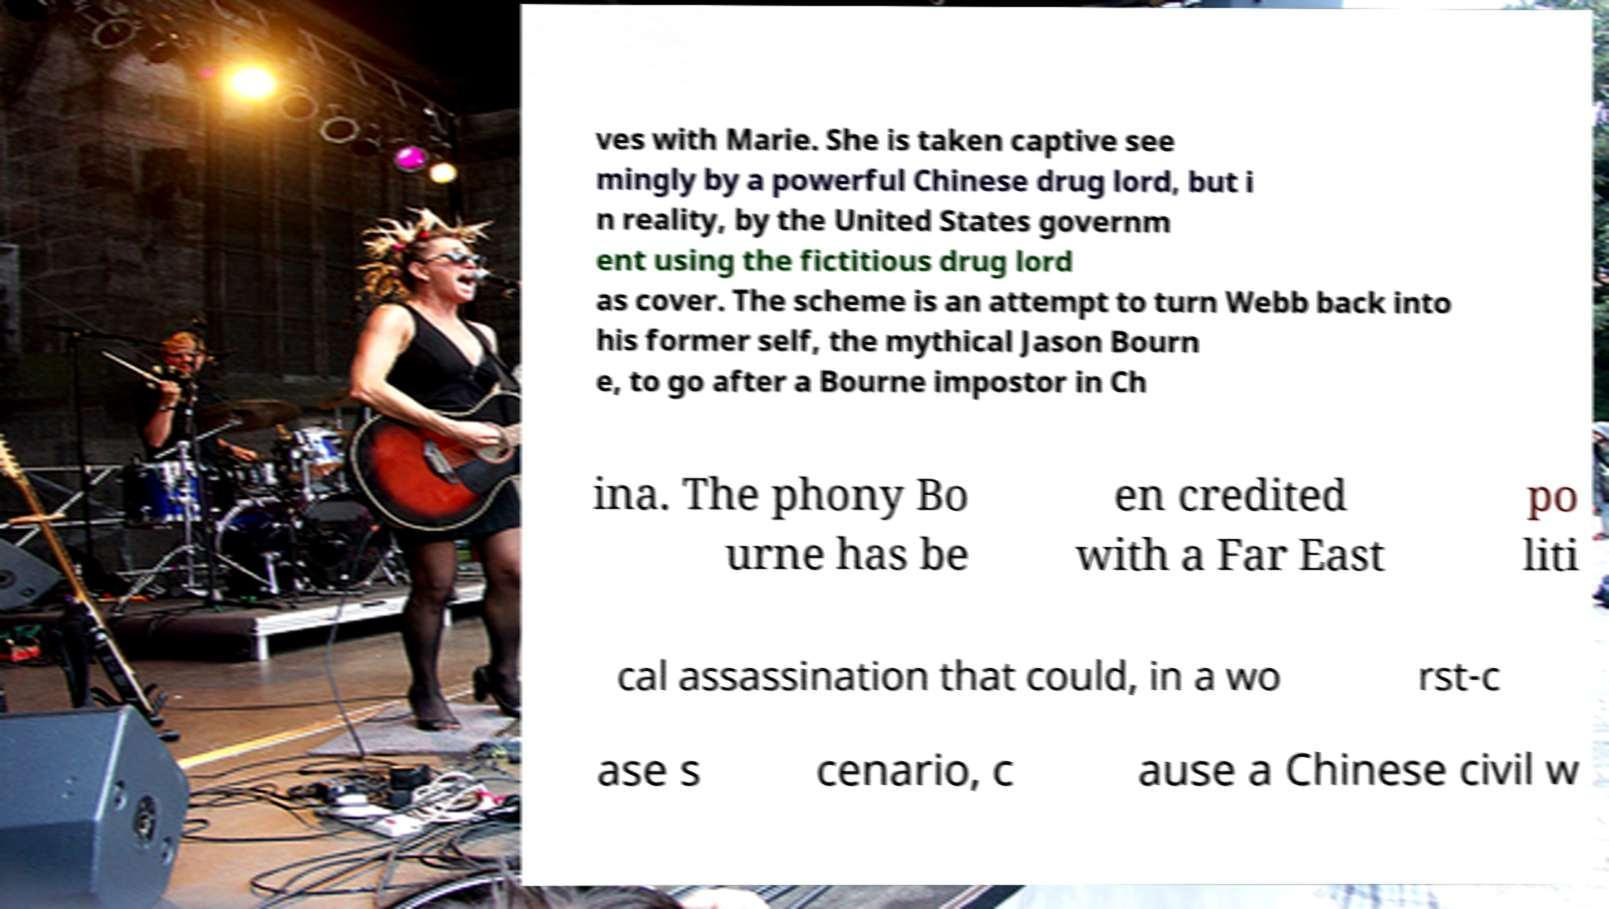What messages or text are displayed in this image? I need them in a readable, typed format. ves with Marie. She is taken captive see mingly by a powerful Chinese drug lord, but i n reality, by the United States governm ent using the fictitious drug lord as cover. The scheme is an attempt to turn Webb back into his former self, the mythical Jason Bourn e, to go after a Bourne impostor in Ch ina. The phony Bo urne has be en credited with a Far East po liti cal assassination that could, in a wo rst-c ase s cenario, c ause a Chinese civil w 